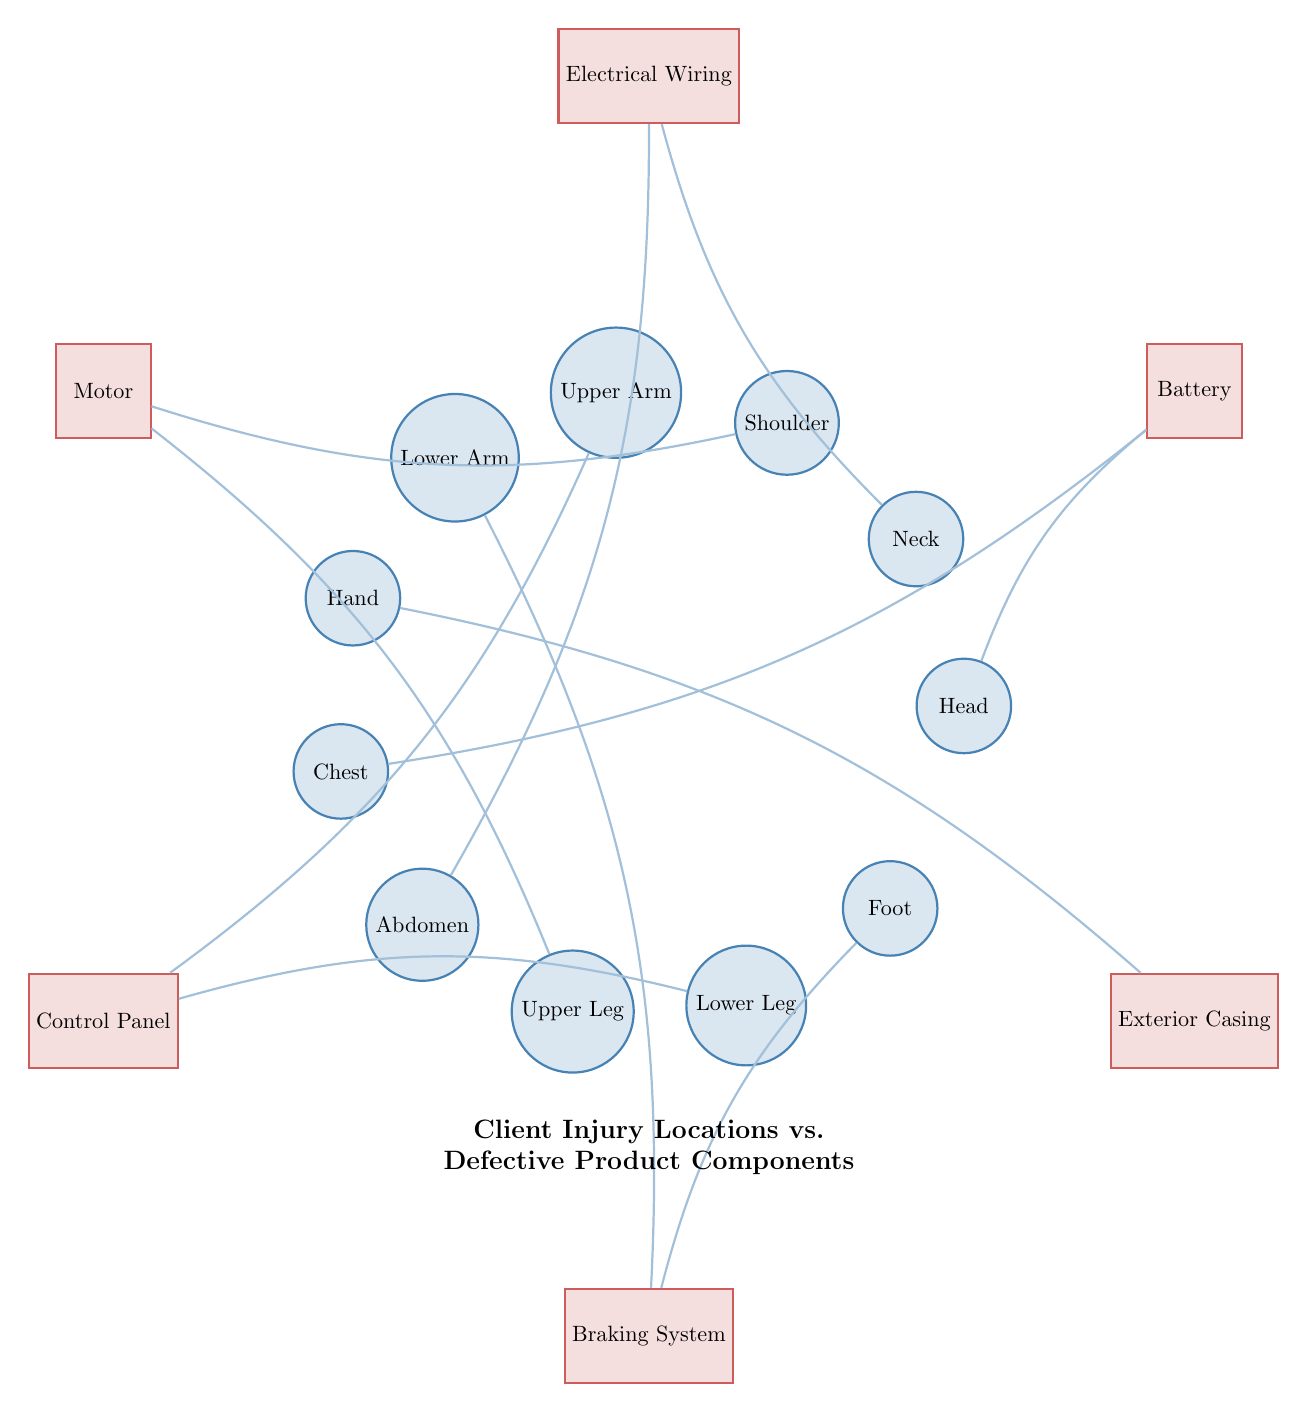What are the injury locations represented in the diagram? The injury locations are the nodes on the left side of the diagram, which are: Head, Neck, Shoulder, Upper Arm, Lower Arm, Hand, Chest, Abdomen, Upper Leg, Lower Leg, and Foot.
Answer: Head, Neck, Shoulder, Upper Arm, Lower Arm, Hand, Chest, Abdomen, Upper Leg, Lower Leg, Foot Which defective product component is linked to the Chest? To find this, look at the connections drawn from the Chest node; there is a line connecting Chest to the Battery.
Answer: Battery How many defective product components are depicted in the diagram? Count the rectangular nodes on the right side of the diagram; there are six: Battery, Electrical Wiring, Motor, Control Panel, Braking System, and Exterior Casing.
Answer: 6 Which injury location has connections to the Battery? Check the connections to the Battery and see that there are two injury locations: Head and Chest.
Answer: Head, Chest What relationship exists between the Lower Leg and Control Panel? There is a connection shown between Lower Leg and Control Panel, indicating that an injury to the Lower Leg may be associated with a defect in the Control Panel.
Answer: Connected Which product component is associated with multiple injury locations? Looking at the connections, the Motor is linked to both Shoulder and Upper Leg, indicating it is associated with multiple injury locations.
Answer: Motor Which injury location is linked to the Exterior Casing? The connection to Exterior Casing is seen specifically with the Hand injury location.
Answer: Hand What is the total number of connections (edges) in the diagram? By counting all the lines drawn between the injury locations and the defective product components, there are eleven connections in total represented in the diagram.
Answer: 11 Which injury location is directly connected to the Braking System? Inspect the connections for the Braking System; the Lower Arm and Foot have direct links to this component.
Answer: Lower Arm, Foot 